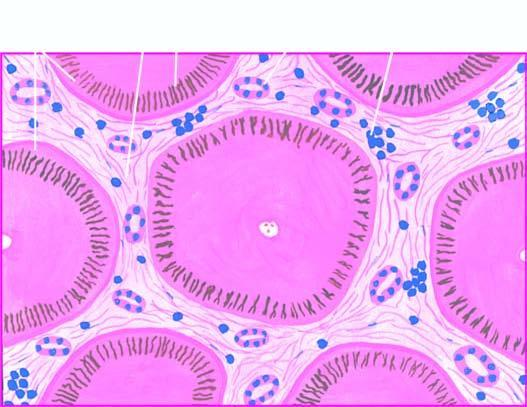what do many of the hepatocytes contain?
Answer the question using a single word or phrase. Elongated bile plugs 